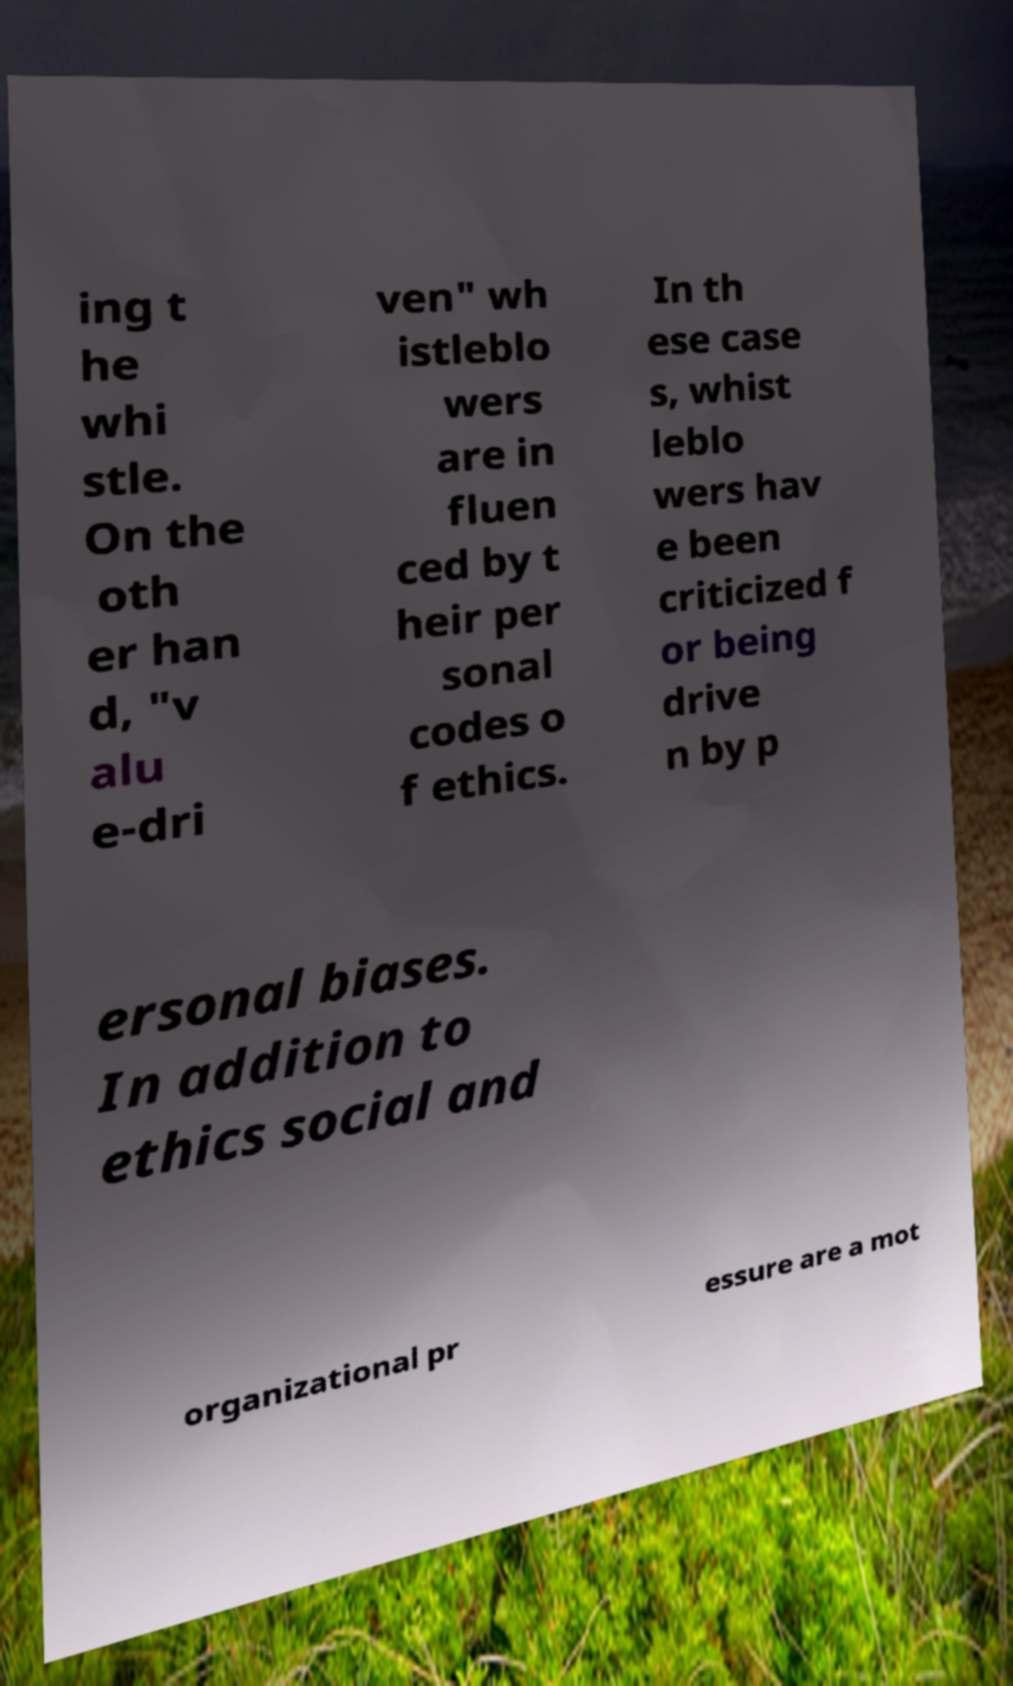Please identify and transcribe the text found in this image. ing t he whi stle. On the oth er han d, "v alu e-dri ven" wh istleblo wers are in fluen ced by t heir per sonal codes o f ethics. In th ese case s, whist leblo wers hav e been criticized f or being drive n by p ersonal biases. In addition to ethics social and organizational pr essure are a mot 